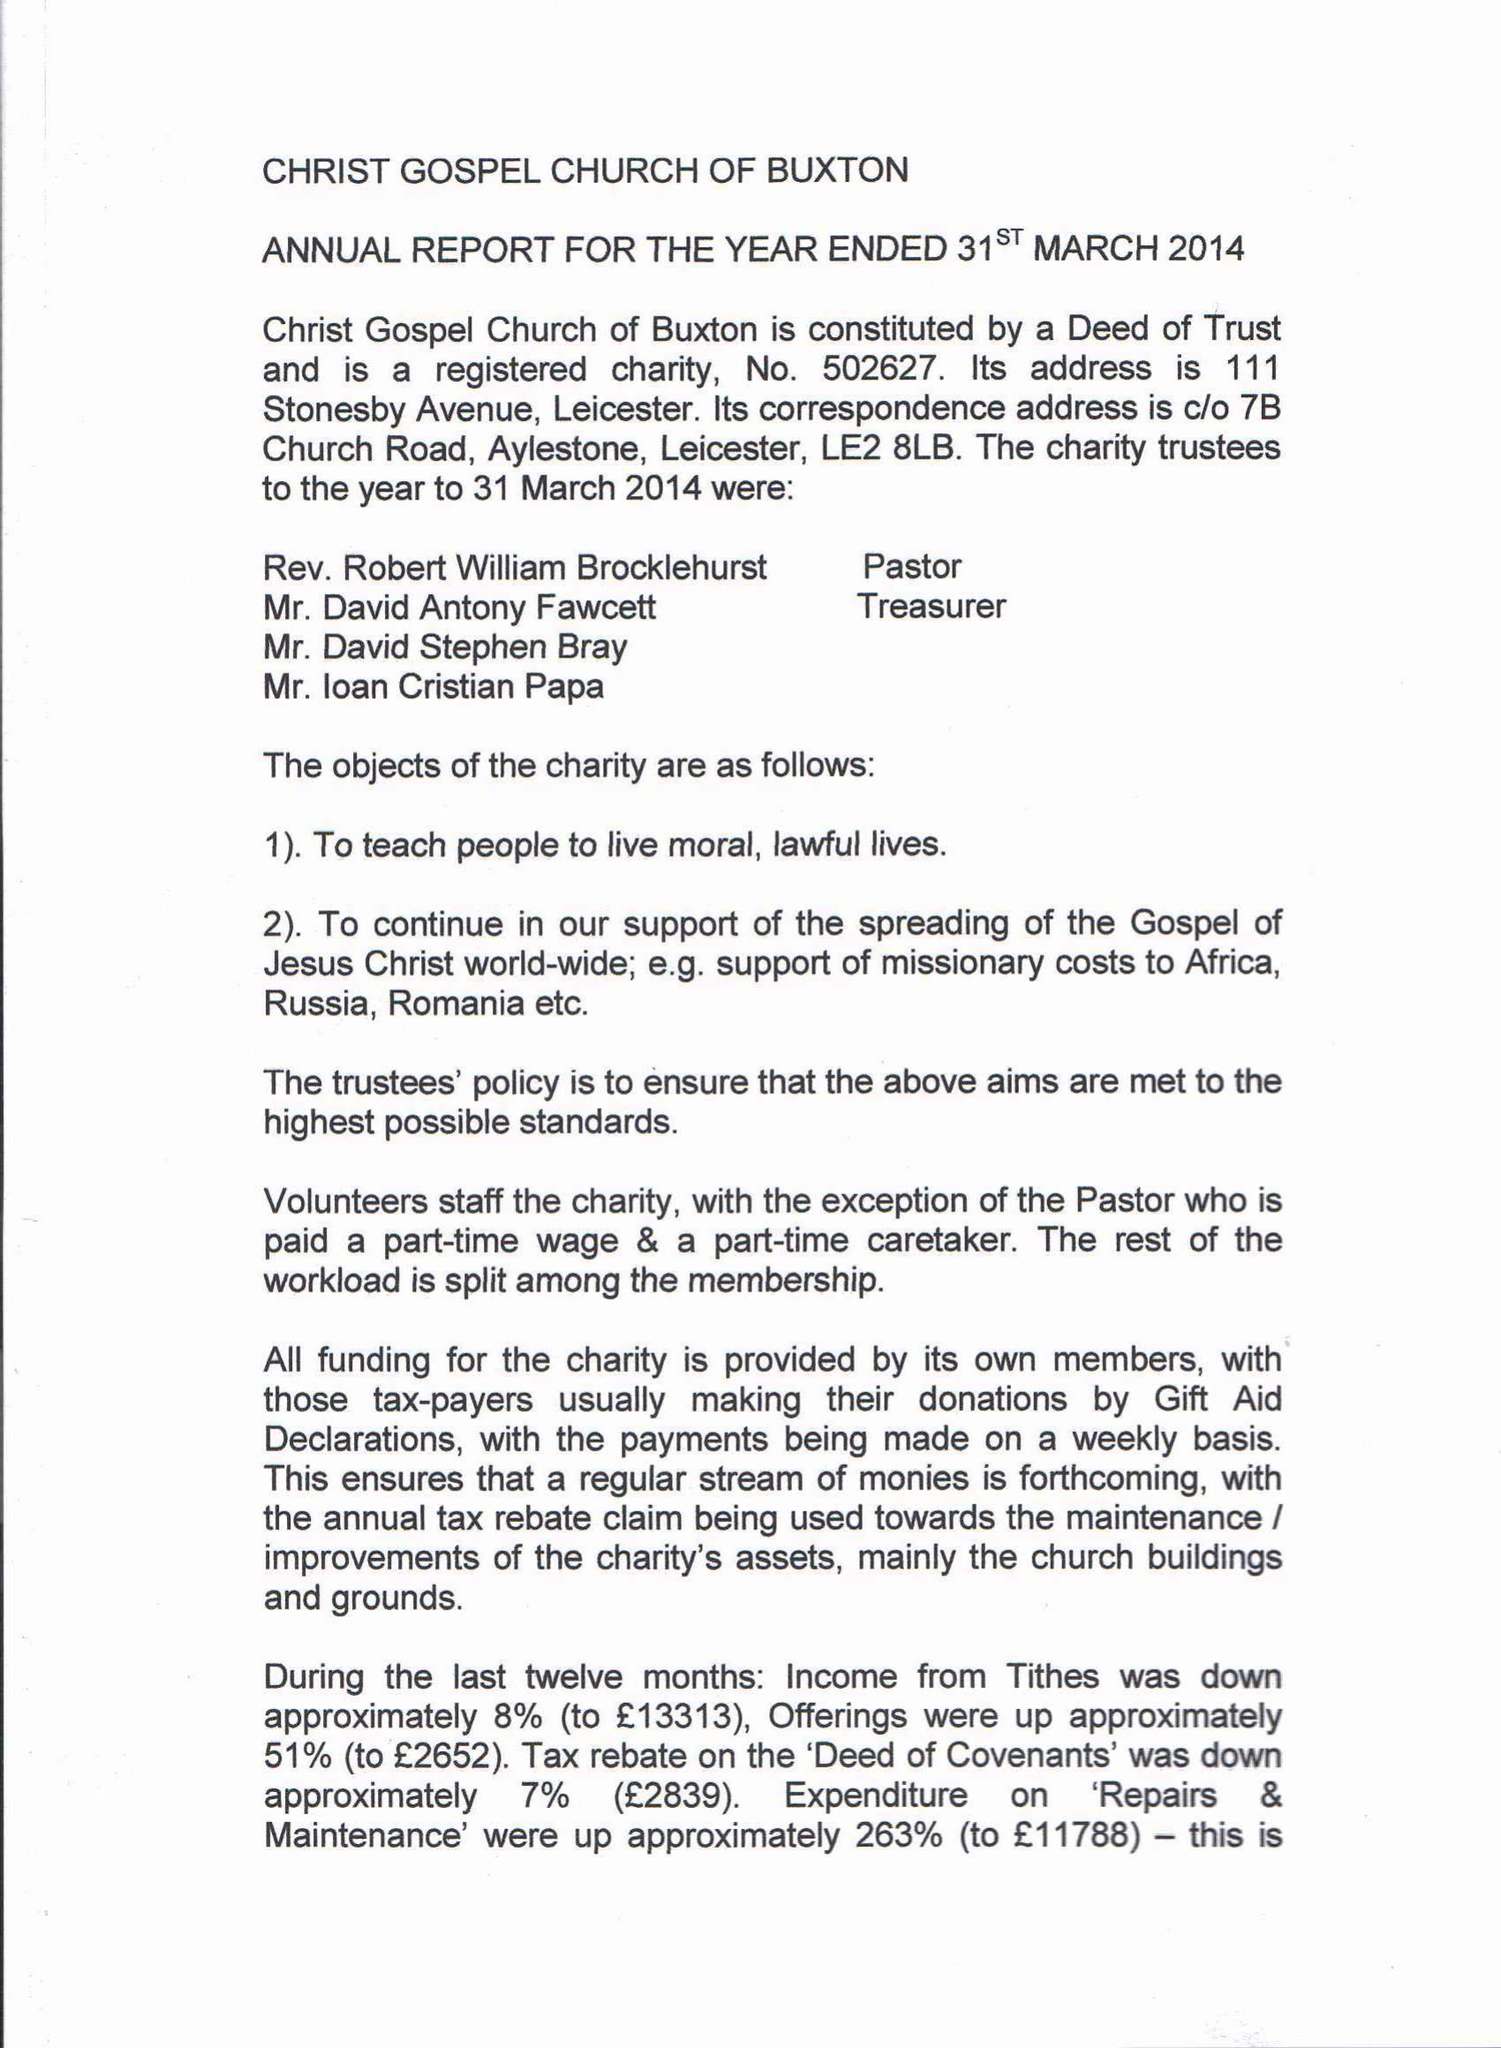What is the value for the report_date?
Answer the question using a single word or phrase. 2014-03-31 